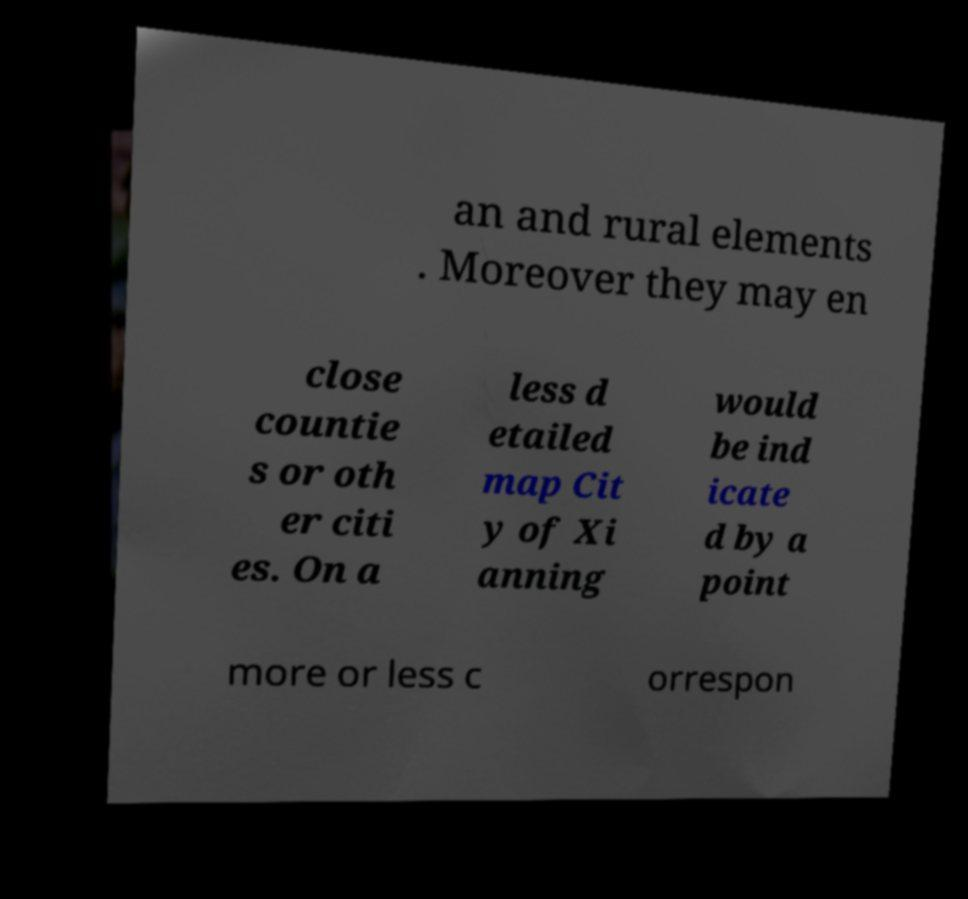Could you extract and type out the text from this image? an and rural elements . Moreover they may en close countie s or oth er citi es. On a less d etailed map Cit y of Xi anning would be ind icate d by a point more or less c orrespon 